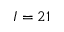Convert formula to latex. <formula><loc_0><loc_0><loc_500><loc_500>I = 2 1</formula> 